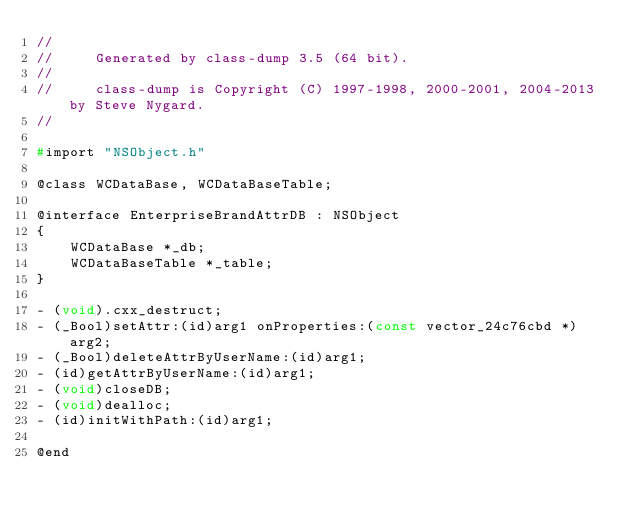<code> <loc_0><loc_0><loc_500><loc_500><_C_>//
//     Generated by class-dump 3.5 (64 bit).
//
//     class-dump is Copyright (C) 1997-1998, 2000-2001, 2004-2013 by Steve Nygard.
//

#import "NSObject.h"

@class WCDataBase, WCDataBaseTable;

@interface EnterpriseBrandAttrDB : NSObject
{
    WCDataBase *_db;
    WCDataBaseTable *_table;
}

- (void).cxx_destruct;
- (_Bool)setAttr:(id)arg1 onProperties:(const vector_24c76cbd *)arg2;
- (_Bool)deleteAttrByUserName:(id)arg1;
- (id)getAttrByUserName:(id)arg1;
- (void)closeDB;
- (void)dealloc;
- (id)initWithPath:(id)arg1;

@end

</code> 